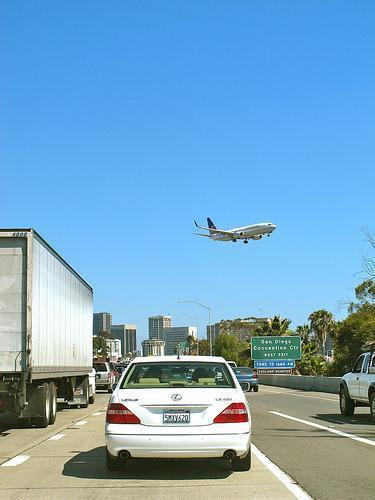How many aeroplanes are there?
Give a very brief answer. 1. 